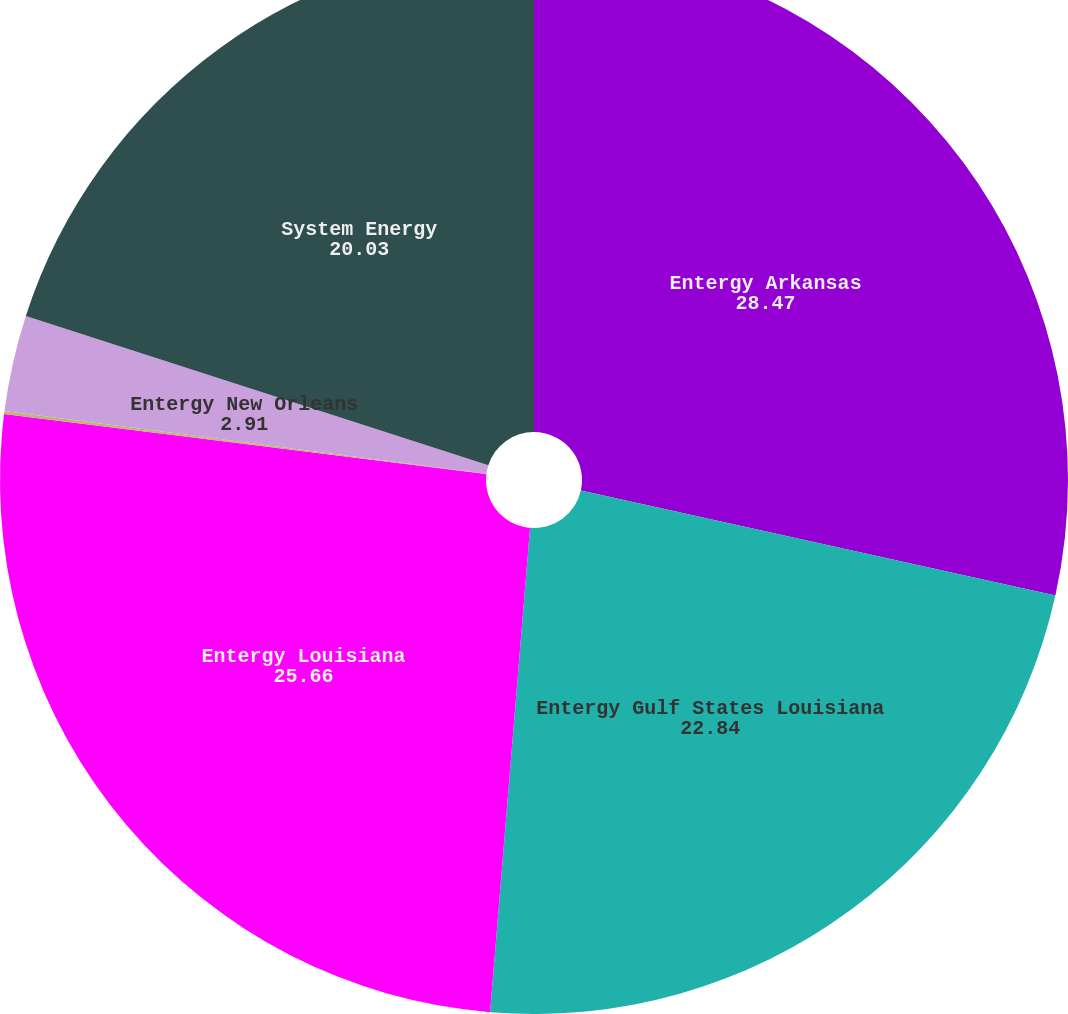Convert chart to OTSL. <chart><loc_0><loc_0><loc_500><loc_500><pie_chart><fcel>Entergy Arkansas<fcel>Entergy Gulf States Louisiana<fcel>Entergy Louisiana<fcel>Entergy Mississippi<fcel>Entergy New Orleans<fcel>System Energy<nl><fcel>28.47%<fcel>22.84%<fcel>25.66%<fcel>0.09%<fcel>2.91%<fcel>20.03%<nl></chart> 